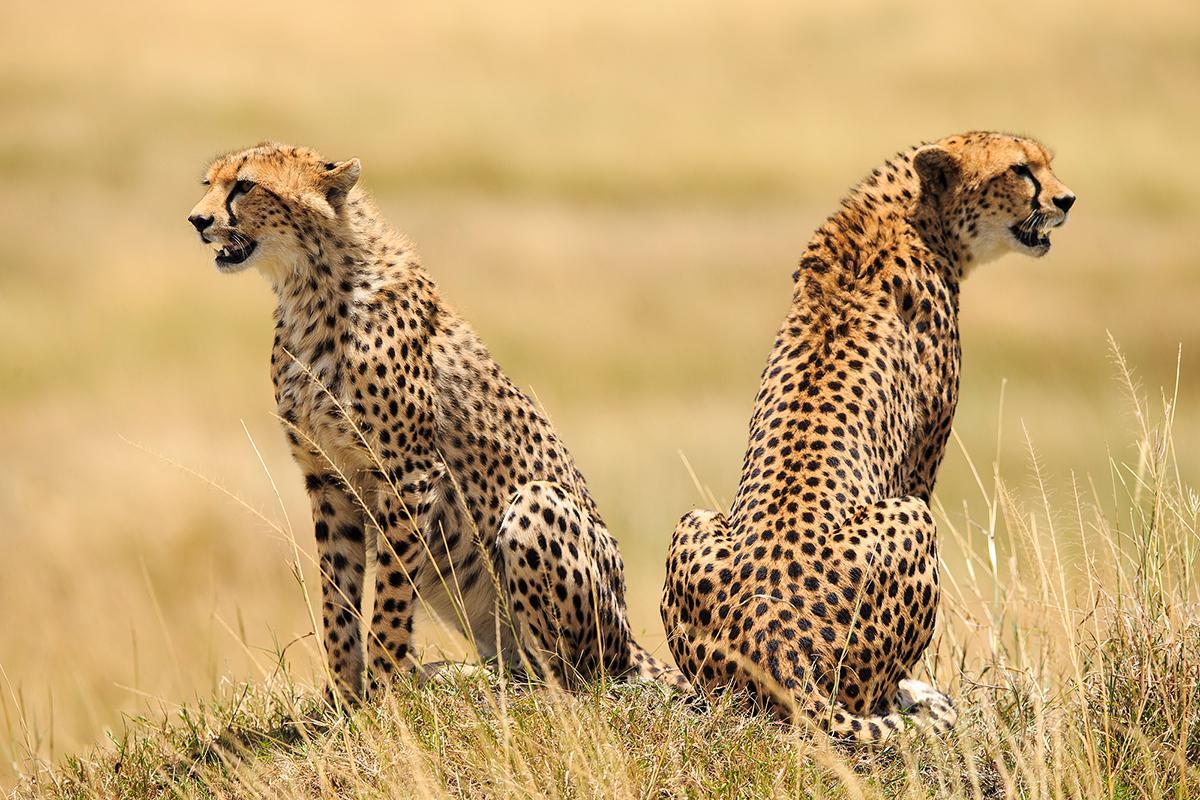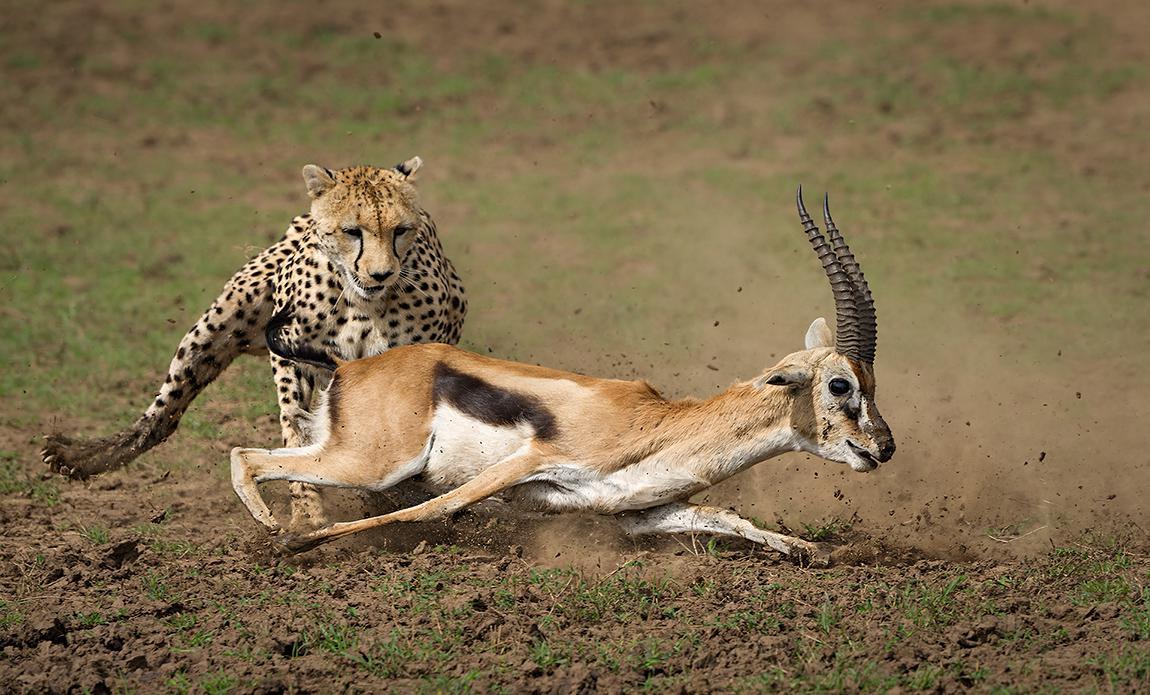The first image is the image on the left, the second image is the image on the right. Analyze the images presented: Is the assertion "At least one image shows a spotted wild cat pursuing a gazelle-type prey animal." valid? Answer yes or no. Yes. The first image is the image on the left, the second image is the image on the right. For the images displayed, is the sentence "At least one of the animals is chasing its prey." factually correct? Answer yes or no. Yes. 